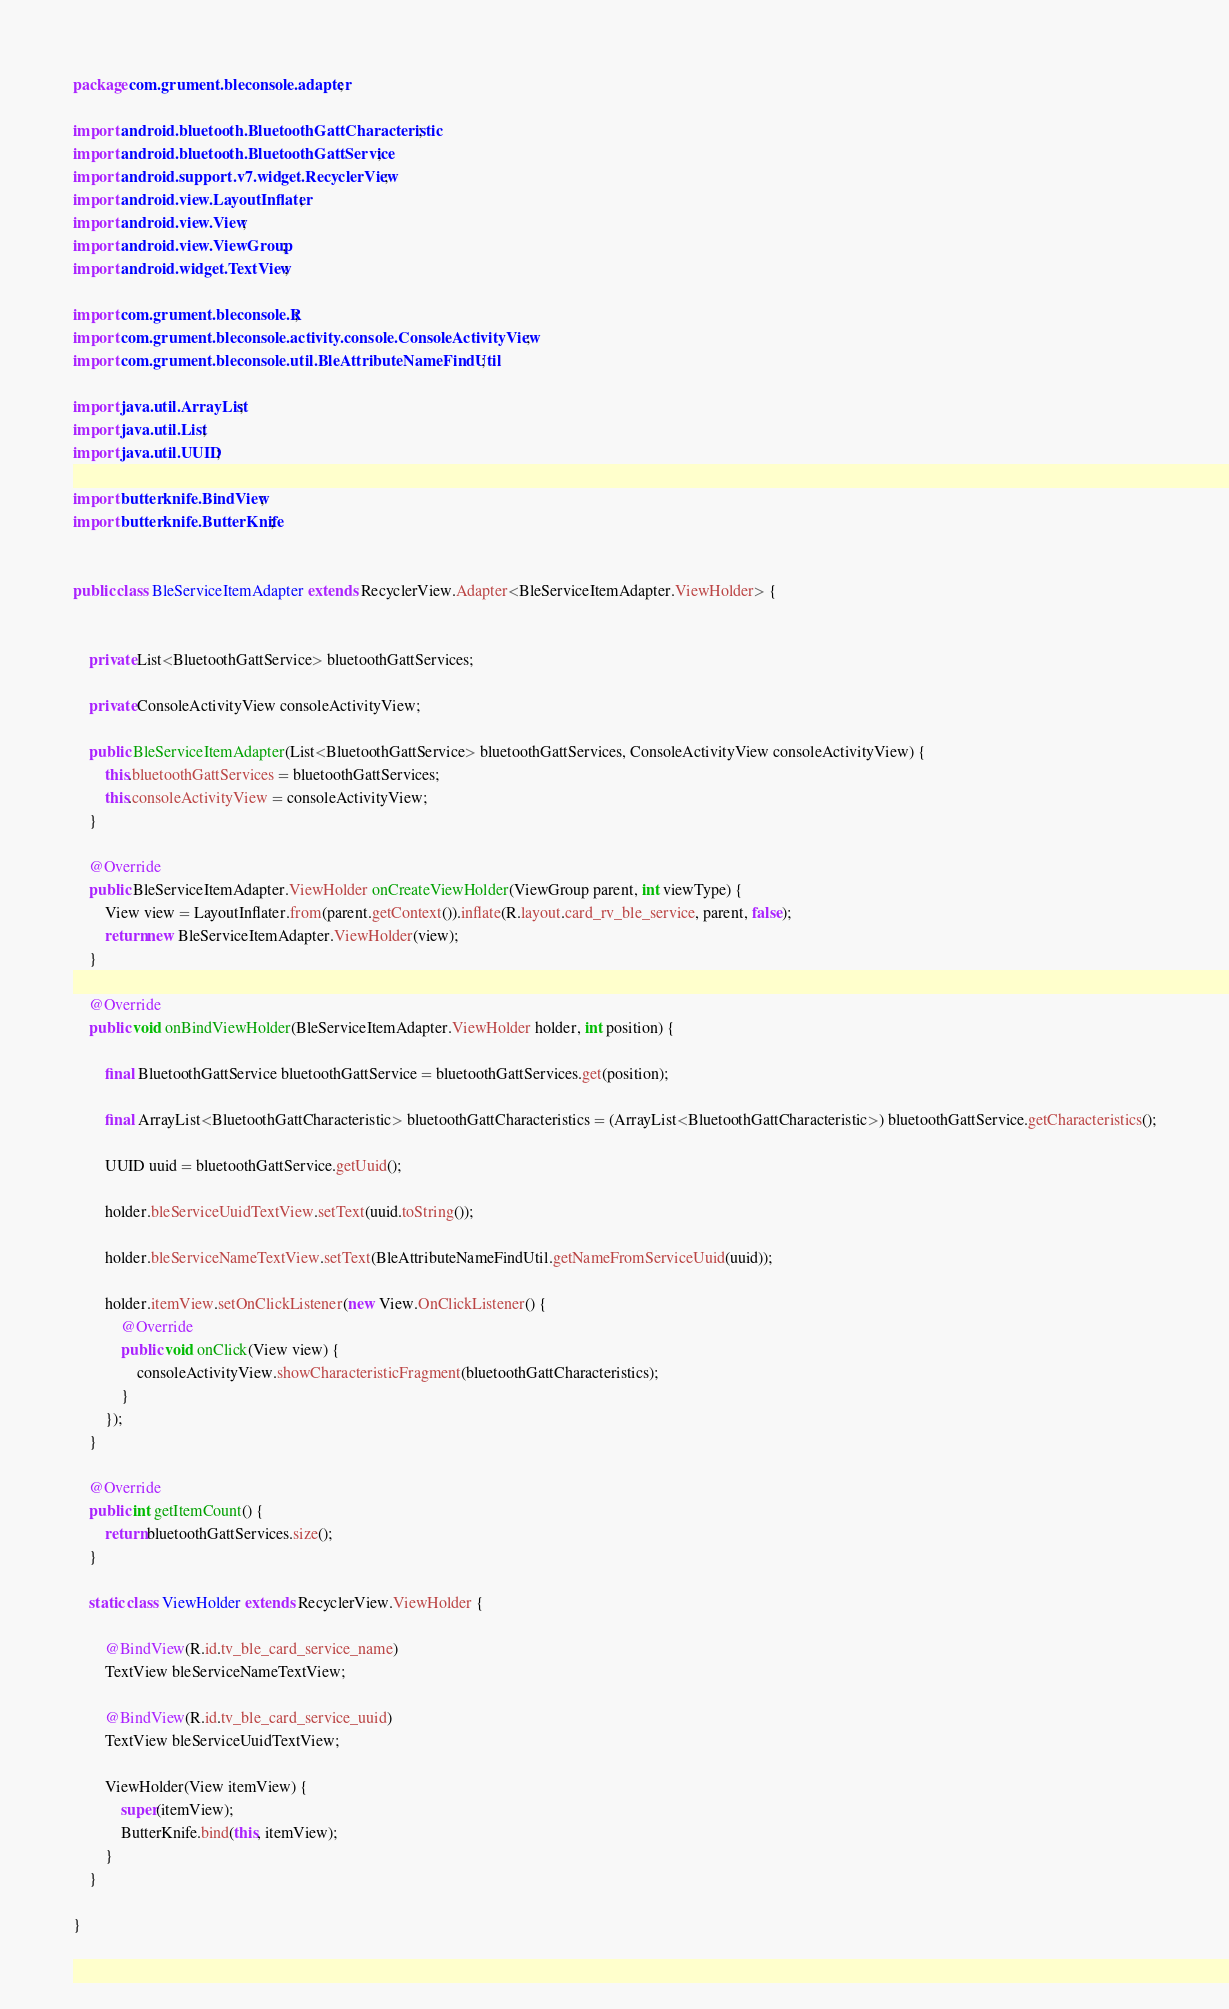Convert code to text. <code><loc_0><loc_0><loc_500><loc_500><_Java_>package com.grument.bleconsole.adapter;

import android.bluetooth.BluetoothGattCharacteristic;
import android.bluetooth.BluetoothGattService;
import android.support.v7.widget.RecyclerView;
import android.view.LayoutInflater;
import android.view.View;
import android.view.ViewGroup;
import android.widget.TextView;

import com.grument.bleconsole.R;
import com.grument.bleconsole.activity.console.ConsoleActivityView;
import com.grument.bleconsole.util.BleAttributeNameFindUtil;

import java.util.ArrayList;
import java.util.List;
import java.util.UUID;

import butterknife.BindView;
import butterknife.ButterKnife;


public class BleServiceItemAdapter extends RecyclerView.Adapter<BleServiceItemAdapter.ViewHolder> {


    private List<BluetoothGattService> bluetoothGattServices;

    private ConsoleActivityView consoleActivityView;

    public BleServiceItemAdapter(List<BluetoothGattService> bluetoothGattServices, ConsoleActivityView consoleActivityView) {
        this.bluetoothGattServices = bluetoothGattServices;
        this.consoleActivityView = consoleActivityView;
    }

    @Override
    public BleServiceItemAdapter.ViewHolder onCreateViewHolder(ViewGroup parent, int viewType) {
        View view = LayoutInflater.from(parent.getContext()).inflate(R.layout.card_rv_ble_service, parent, false);
        return new BleServiceItemAdapter.ViewHolder(view);
    }

    @Override
    public void onBindViewHolder(BleServiceItemAdapter.ViewHolder holder, int position) {

        final BluetoothGattService bluetoothGattService = bluetoothGattServices.get(position);

        final ArrayList<BluetoothGattCharacteristic> bluetoothGattCharacteristics = (ArrayList<BluetoothGattCharacteristic>) bluetoothGattService.getCharacteristics();

        UUID uuid = bluetoothGattService.getUuid();

        holder.bleServiceUuidTextView.setText(uuid.toString());

        holder.bleServiceNameTextView.setText(BleAttributeNameFindUtil.getNameFromServiceUuid(uuid));

        holder.itemView.setOnClickListener(new View.OnClickListener() {
            @Override
            public void onClick(View view) {
                consoleActivityView.showCharacteristicFragment(bluetoothGattCharacteristics);
            }
        });
    }

    @Override
    public int getItemCount() {
        return bluetoothGattServices.size();
    }

    static class ViewHolder extends RecyclerView.ViewHolder {

        @BindView(R.id.tv_ble_card_service_name)
        TextView bleServiceNameTextView;

        @BindView(R.id.tv_ble_card_service_uuid)
        TextView bleServiceUuidTextView;

        ViewHolder(View itemView) {
            super(itemView);
            ButterKnife.bind(this, itemView);
        }
    }

}
</code> 